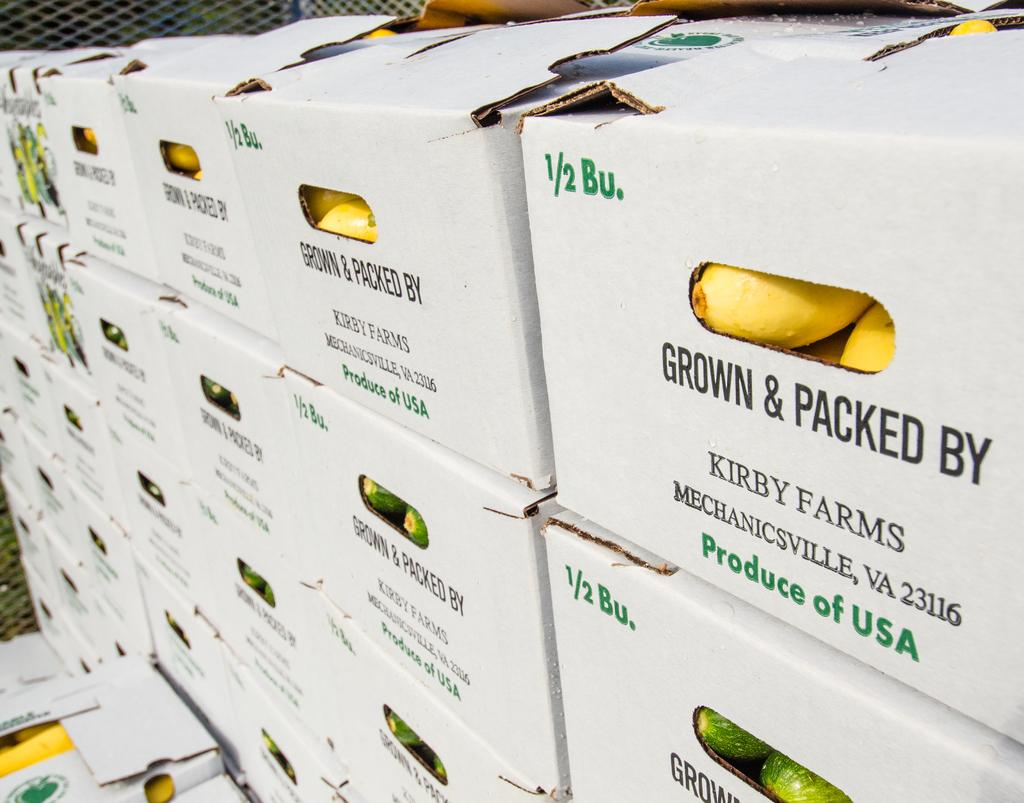What objects can be seen in the image? There are boxes in the image. What can be seen in the background of the image? There is a mesh in the background of the image. How many stars can be seen in the image? There are no stars present in the image; it only contains boxes and a mesh background. 